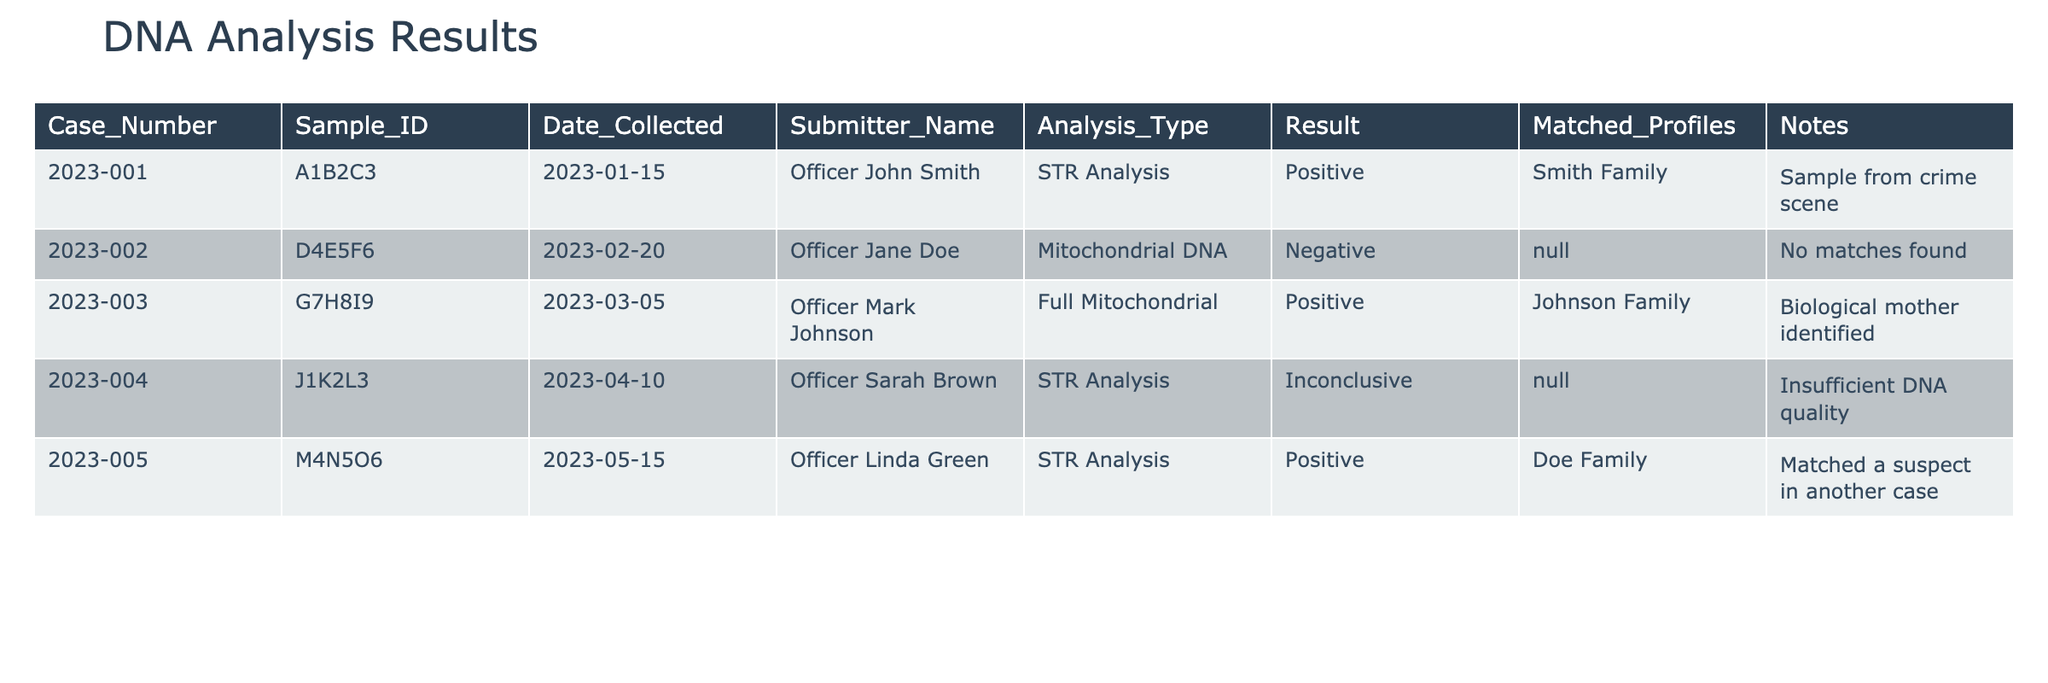What is the result of Case Number 2023-001? The result for Case Number 2023-001 is listed in the table as "Positive." This is directly found in the "Result" column corresponding to the specified case number.
Answer: Positive Which sample has a Negative result? The table shows that Case Number 2023-002 has a "Negative" result. This can be found by looking at the "Result" column for the respective case.
Answer: 2023-002 How many cases resulted in a Positive finding? Looking at the "Result" column, there are three cases (2023-001, 2023-003, and 2023-005) that have a "Positive" result, so the count is three.
Answer: 3 Is there a case with Inconclusive results? Yes, Case Number 2023-004 has an "Inconclusive" result. This can be determined by checking the "Result" column for each case.
Answer: Yes Which submitter identified a biological mother? The submitter who identified a biological mother is Officer Mark Johnson through Case Number 2023-003. This information is noted in the "Notes" column, which indicates that the biological mother was identified.
Answer: Officer Mark Johnson How many total cases are analyzed in the table? The table has a total of five cases listed, as indicated by the number of rows corresponding to individual case entries.
Answer: 5 Of the Positive results, how many matched with profiles? Two cases (2023-001 and 2023-005) have matched profiles listed under "Matched_Profiles"; thus, the number is two.
Answer: 2 What is the date collected for the STR Analysis with an inconclusive result? The STR Analysis which resulted in "Inconclusive" corresponds to Case Number 2023-004, collected on 2023-04-10, found in the "Date_Collected" column.
Answer: 2023-04-10 Are there any matches found for Case Number 2023-002? No, for Case Number 2023-002, the "Matched_Profiles" column states "N/A," indicating no matches were found pertaining to this case.
Answer: No 